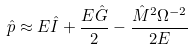<formula> <loc_0><loc_0><loc_500><loc_500>\hat { p } \approx E \hat { I } + \frac { E \hat { G } } { 2 } - \frac { \hat { M } ^ { 2 } \Omega ^ { - 2 } } { 2 E }</formula> 